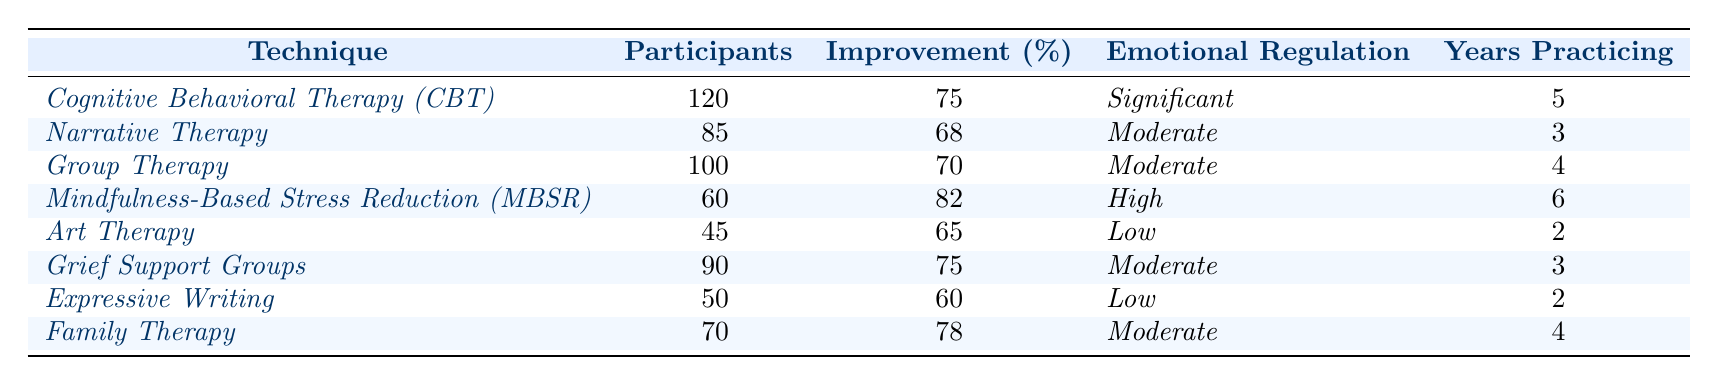What is the technique with the highest improvement percentage? By reviewing the "Improvement (%)" column, we see that the highest percentage is 82% for "Mindfulness-Based Stress Reduction (MBSR)."
Answer: Mindfulness-Based Stress Reduction (MBSR) How many participants were involved in Family Therapy? The "Participants" column indicates that there were 70 participants involved in Family Therapy.
Answer: 70 Which techniques show a significant level of emotional regulation? Referring to the "Emotional Regulation" column, the techniques with "Significant" emotional regulation are Cognitive Behavioral Therapy (CBT) and Mindfulness-Based Stress Reduction (MBSR).
Answer: Cognitive Behavioral Therapy (CBT) and Mindfulness-Based Stress Reduction (MBSR) What is the average improvement percentage of all therapies listed? The improvement percentages are: 75, 68, 70, 82, 65, 75, 60, and 78. Summing these values gives 75 + 68 + 70 + 82 + 65 + 75 + 60 + 78 = 603. Dividing this total by 8 (the number of techniques), we find the average improvement percentage is 603/8 = 75.375.
Answer: 75.375 Is there any therapy that reports low emotional regulation with a higher improvement percentage than 60%? Checking the techniques categorized as "Low" emotional regulation, we find that Art Therapy has an improvement percentage of 65%, and Expressive Writing has 60%. Since Art Therapy exceeds 60%, the answer is yes.
Answer: Yes What is the difference in improvement percentage between the highest and lowest technique? The highest improvement percentage is 82% (Mindfulness-Based Stress Reduction), and the lowest is 60% (Expressive Writing). The difference is calculated as 82 - 60 = 22%.
Answer: 22% Which therapy had the least number of participants? Looking at the "Participants" column, Art Therapy has the least number of participants with a total of 45.
Answer: Art Therapy How many techniques have moderate emotional regulation? From the "Emotional Regulation" column, we can see that Narrative Therapy, Group Therapy, Grief Support Groups, and Family Therapy all have moderate emotional regulation. Counting these gives us 4 techniques.
Answer: 4 What percentage improvement did Art Therapy achieve compared to Family Therapy? Art Therapy had a 65% improvement, while Family Therapy achieved 78%. To find the difference, we calculate 78 - 65 = 13%. Family Therapy improved more by 13 percentage points.
Answer: 13% 